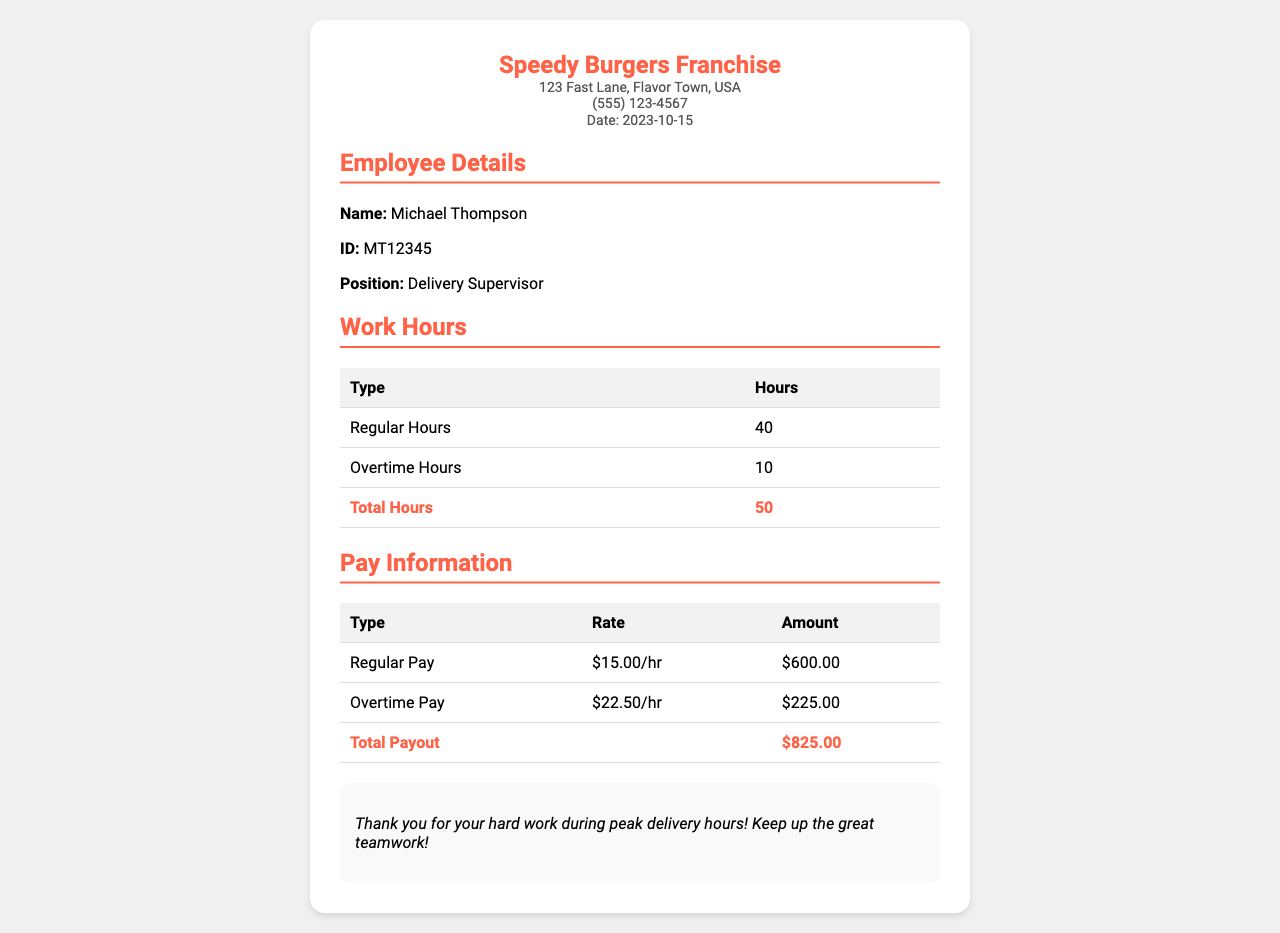what is the employee's name? The employee's name is listed at the top of the document under Employee Details.
Answer: Michael Thompson what is the employee's ID? The employee's ID is provided right below the name in the Employee Details section.
Answer: MT12345 what is the date of this pay statement? The date is mentioned in the header section of the receipt.
Answer: 2023-10-15 how many overtime hours did the employee work? The number of overtime hours worked is detailed in the Work Hours section.
Answer: 10 what is the regular hourly rate? The regular hourly rate is presented in the Pay Information section under the Regular Pay row.
Answer: $15.00/hr what is the total payout amount? The total payout can be found at the end of the Pay Information table.
Answer: $825.00 how many total hours did the employee work? The total hours worked is the sum of regular and overtime hours listed in the Work Hours section.
Answer: 50 what is the overtime pay rate? The overtime pay rate is specified in the Pay Information section under the Overtime Pay row.
Answer: $22.50/hr what message is included in the notes section? The notes section contains a message thanking the employee for their work.
Answer: Thank you for your hard work during peak delivery hours! Keep up the great teamwork! 